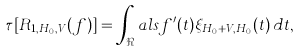Convert formula to latex. <formula><loc_0><loc_0><loc_500><loc_500>\tau [ R _ { 1 , H _ { 0 } , V } ( f ) ] = \int _ { \Re } a l s f ^ { \prime } ( t ) \xi _ { H _ { 0 } + V , H _ { 0 } } ( t ) \, d t ,</formula> 